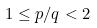<formula> <loc_0><loc_0><loc_500><loc_500>1 \leq p / q < 2</formula> 